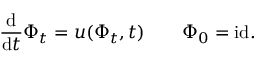Convert formula to latex. <formula><loc_0><loc_0><loc_500><loc_500>\frac { d } { d t } \Phi _ { t } = u ( \Phi _ { t } , t ) \quad \Phi _ { 0 } = i d .</formula> 